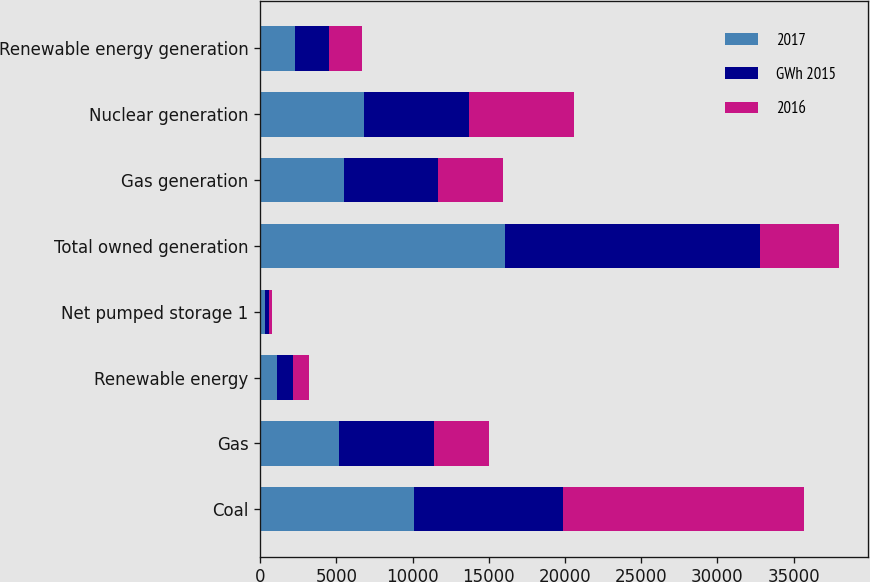Convert chart. <chart><loc_0><loc_0><loc_500><loc_500><stacked_bar_chart><ecel><fcel>Coal<fcel>Gas<fcel>Renewable energy<fcel>Net pumped storage 1<fcel>Total owned generation<fcel>Gas generation<fcel>Nuclear generation<fcel>Renewable energy generation<nl><fcel>2017<fcel>10098<fcel>5190<fcel>1078<fcel>290<fcel>16088<fcel>5521<fcel>6780<fcel>2288<nl><fcel>GWh 2015<fcel>9739<fcel>6194<fcel>1083<fcel>316<fcel>16708<fcel>6139<fcel>6927<fcel>2229<nl><fcel>2016<fcel>15833<fcel>3601<fcel>1056<fcel>186<fcel>5190<fcel>4301<fcel>6909<fcel>2163<nl></chart> 